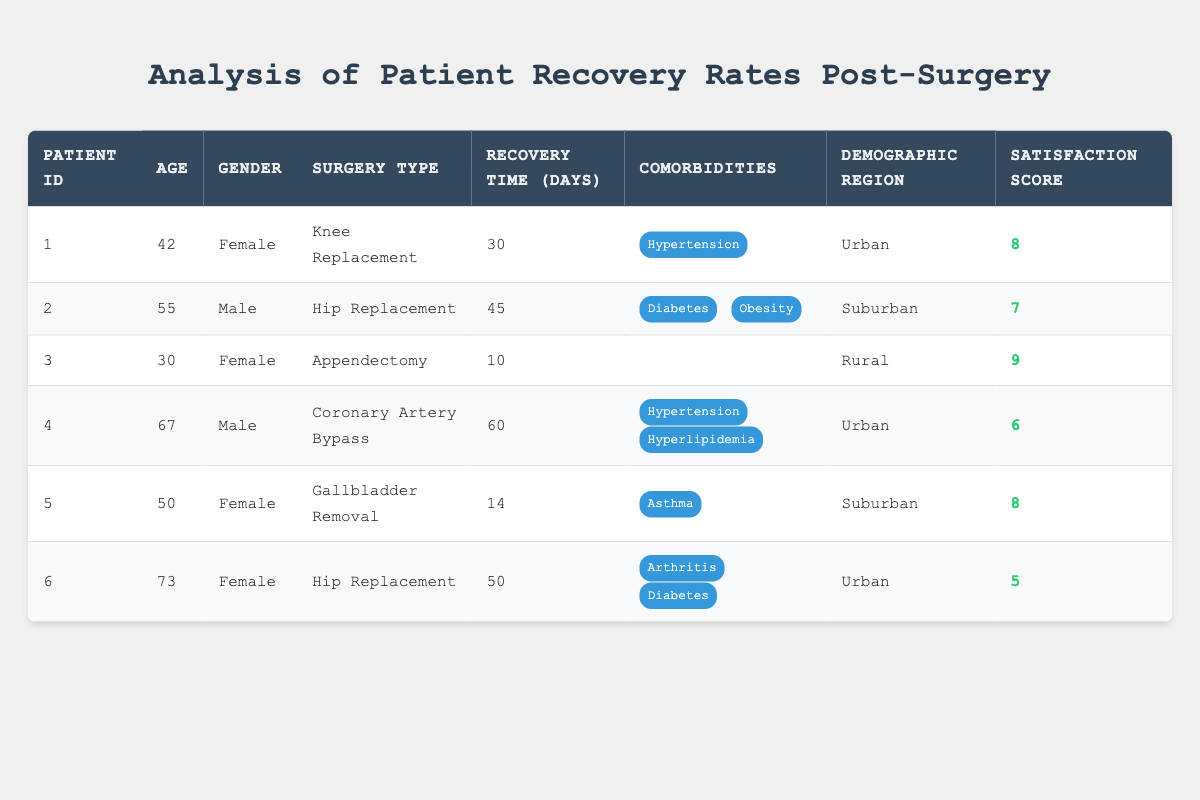What is the recovery time for patient ID 1? The recovery time for patient ID 1 is explicitly stated in the table as 30 days.
Answer: 30 days How many male patients are in the study? There are two male patients listed: patient ID 2 and patient ID 4.
Answer: 2 What is the satisfaction score for the patient with the longest recovery time? Patient ID 4 has the longest recovery time of 60 days, and their satisfaction score is 6.
Answer: 6 Which demographic region had the majority of patients? The regions listed are Urban (3), Suburban (2), and Rural (1). The majority of patients are from the Urban region.
Answer: Urban What is the average recovery time for female patients? The recovery times for female patients are 30 (patient ID 1), 10 (patient ID 3), and 50 (patient ID 6). The average is (30 + 10 + 50) / 3 = 90 / 3 = 30 days.
Answer: 30 days Did any patients report a satisfaction score of 9? Yes, patient ID 3 reported a satisfaction score of 9.
Answer: Yes What is the median recovery time for patients with comorbidities? The recovery times for patients with comorbidities are 30 (patient ID 1), 45 (patient ID 2), 60 (patient ID 4), and 50 (patient ID 6). Sorting these gives 30, 45, 50, 60. The median is (45 + 50) / 2 = 95 / 2 = 47.5 days.
Answer: 47.5 days How many days did the rural patient take to recover compared to the average of all patients? The rural patient (ID 3) took 10 days to recover, while the average recovery time for all patients is calculated as (30 + 45 + 10 + 60 + 14 + 50) / 6 = 209 / 6 = 34.83 days. 10 days is less than 34.83 days.
Answer: Less Is there a female patient in the Urban demographic region with a satisfaction score greater than 7? Yes, patient ID 1 (a female, Urban) has a satisfaction score of 8, which is greater than 7.
Answer: Yes 